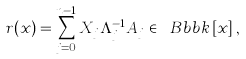<formula> <loc_0><loc_0><loc_500><loc_500>r ( x ) = \sum _ { j = 0 } ^ { n - 1 } X _ { j } \Lambda _ { j } ^ { - 1 } A _ { j } \in \ B b b k \left [ x \right ] ,</formula> 